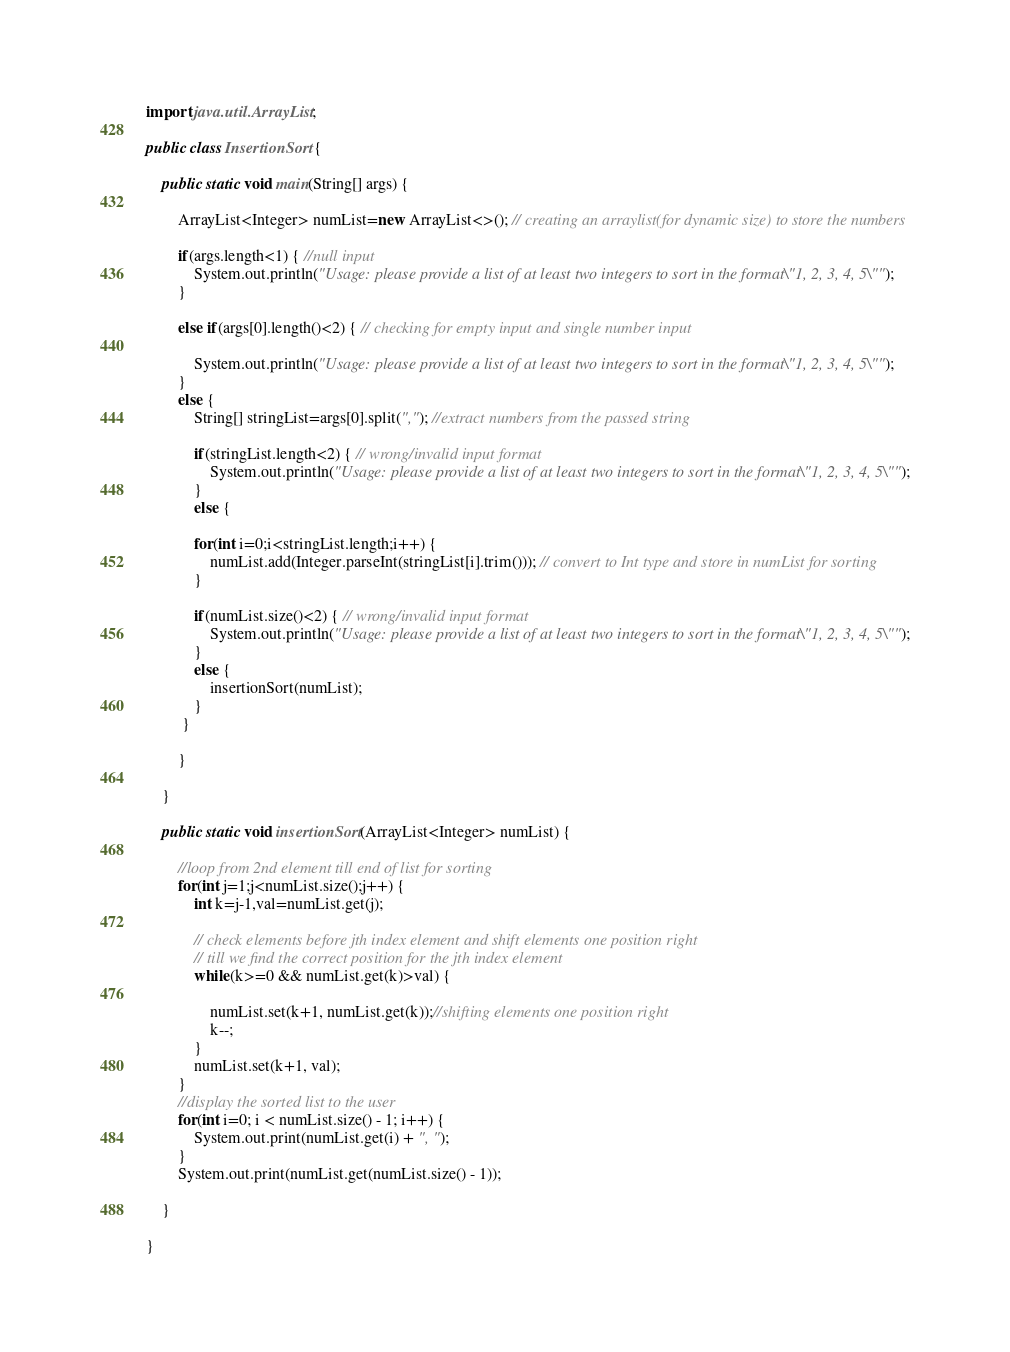<code> <loc_0><loc_0><loc_500><loc_500><_Java_>import java.util.ArrayList;

public class InsertionSort {

    public static void main(String[] args) {

        ArrayList<Integer> numList=new ArrayList<>(); // creating an arraylist(for dynamic size) to store the numbers 
        
        if(args.length<1) { //null input
            System.out.println("Usage: please provide a list of at least two integers to sort in the format \"1, 2, 3, 4, 5\"");
        }

        else if(args[0].length()<2) { // checking for empty input and single number input

            System.out.println("Usage: please provide a list of at least two integers to sort in the format \"1, 2, 3, 4, 5\"");
        }
        else {
            String[] stringList=args[0].split(","); //extract numbers from the passed string
           
            if(stringList.length<2) { // wrong/invalid input format
                System.out.println("Usage: please provide a list of at least two integers to sort in the format \"1, 2, 3, 4, 5\"");
            }
            else {
 
            for(int i=0;i<stringList.length;i++) {
                numList.add(Integer.parseInt(stringList[i].trim())); // convert to Int type and store in numList for sorting
            }

            if(numList.size()<2) { // wrong/invalid input format
                System.out.println("Usage: please provide a list of at least two integers to sort in the format \"1, 2, 3, 4, 5\"");
            }
            else {
                insertionSort(numList);
            }
         }

        }

    }

    public static void insertionSort(ArrayList<Integer> numList) {

        //loop from 2nd element till end of list for sorting
        for(int j=1;j<numList.size();j++) {
            int k=j-1,val=numList.get(j);

            // check elements before jth index element and shift elements one position right  
            // till we find the correct position for the jth index element
            while(k>=0 && numList.get(k)>val) {

                numList.set(k+1, numList.get(k));//shifting elements one position right
                k--;
            }
            numList.set(k+1, val);
        }
        //display the sorted list to the user
        for(int i=0; i < numList.size() - 1; i++) {
            System.out.print(numList.get(i) + ", ");
        }
        System.out.print(numList.get(numList.size() - 1));
        
    }

}
</code> 